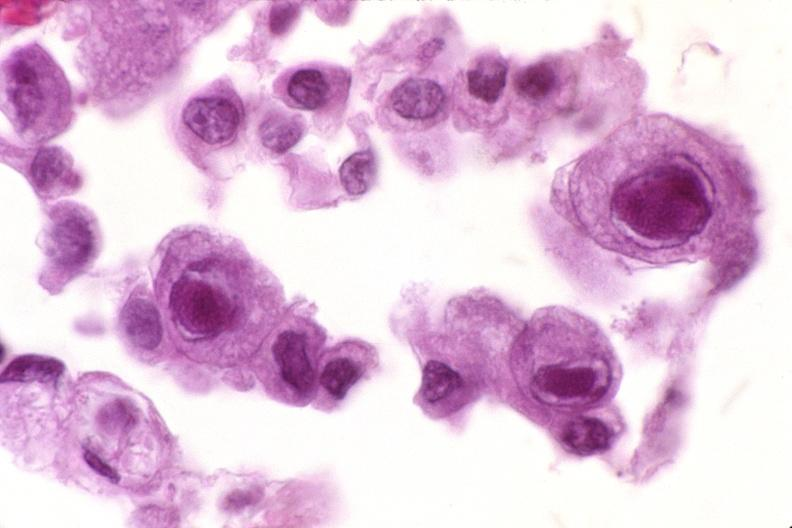does granulosa cell tumor show lung, cyomegalovirus pneumonia?
Answer the question using a single word or phrase. No 